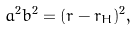Convert formula to latex. <formula><loc_0><loc_0><loc_500><loc_500>a ^ { 2 } b ^ { 2 } = ( r - r _ { H } ) ^ { 2 } ,</formula> 